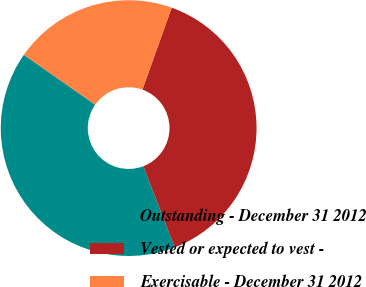Convert chart to OTSL. <chart><loc_0><loc_0><loc_500><loc_500><pie_chart><fcel>Outstanding - December 31 2012<fcel>Vested or expected to vest -<fcel>Exercisable - December 31 2012<nl><fcel>40.57%<fcel>38.68%<fcel>20.75%<nl></chart> 